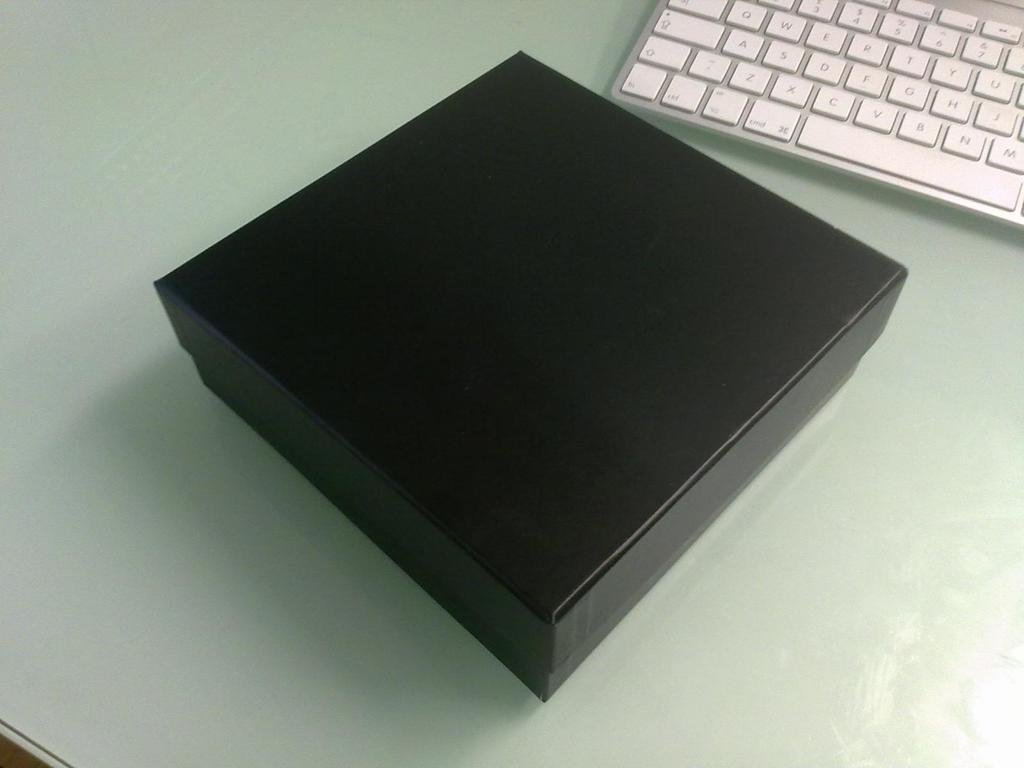<image>
Present a compact description of the photo's key features. ASDFG is shown on the keyboard beside a large black box. 